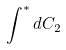Convert formula to latex. <formula><loc_0><loc_0><loc_500><loc_500>\int ^ { * } d C _ { 2 }</formula> 